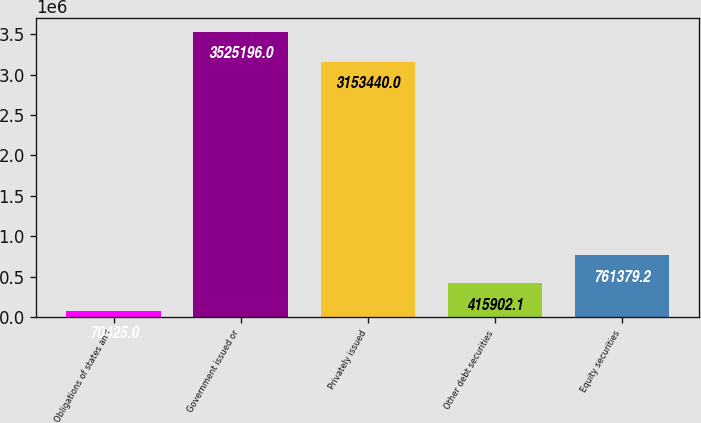<chart> <loc_0><loc_0><loc_500><loc_500><bar_chart><fcel>Obligations of states and<fcel>Government issued or<fcel>Privately issued<fcel>Other debt securities<fcel>Equity securities<nl><fcel>70425<fcel>3.5252e+06<fcel>3.15344e+06<fcel>415902<fcel>761379<nl></chart> 